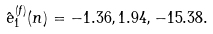<formula> <loc_0><loc_0><loc_500><loc_500>\hat { e } ^ { ( f ) } _ { 1 } ( n ) = - 1 . 3 6 , 1 . 9 4 , - 1 5 . 3 8 .</formula> 